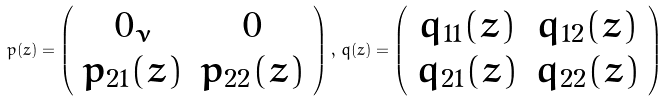<formula> <loc_0><loc_0><loc_500><loc_500>p ( z ) = \left ( \begin{array} { c c } 0 _ { \nu } & 0 \\ p _ { 2 1 } ( z ) & p _ { 2 2 } ( z ) \end{array} \right ) , \, q ( z ) = \left ( \begin{array} { c c } q _ { 1 1 } ( z ) & q _ { 1 2 } ( z ) \\ q _ { 2 1 } ( z ) & q _ { 2 2 } ( z ) \end{array} \right )</formula> 